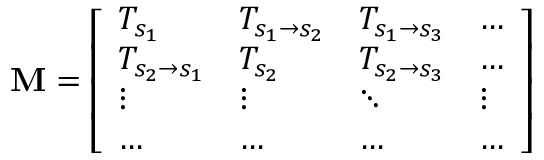Convert formula to latex. <formula><loc_0><loc_0><loc_500><loc_500>M = \left [ \begin{array} { l l l l } { T _ { s _ { 1 } } } & { T _ { s _ { 1 } \rightarrow s _ { 2 } } } & { T _ { s _ { 1 } \rightarrow s _ { 3 } } } & { \dots } \\ { T _ { s _ { 2 } \rightarrow s _ { 1 } } } & { T _ { s _ { 2 } } } & { T _ { s _ { 2 } \rightarrow s _ { 3 } } } & { \dots } \\ { \vdots } & { \vdots } & { \ddots } & { \vdots } \\ { \dots } & { \dots } & { \dots } & { \dots } \end{array} \right ]</formula> 